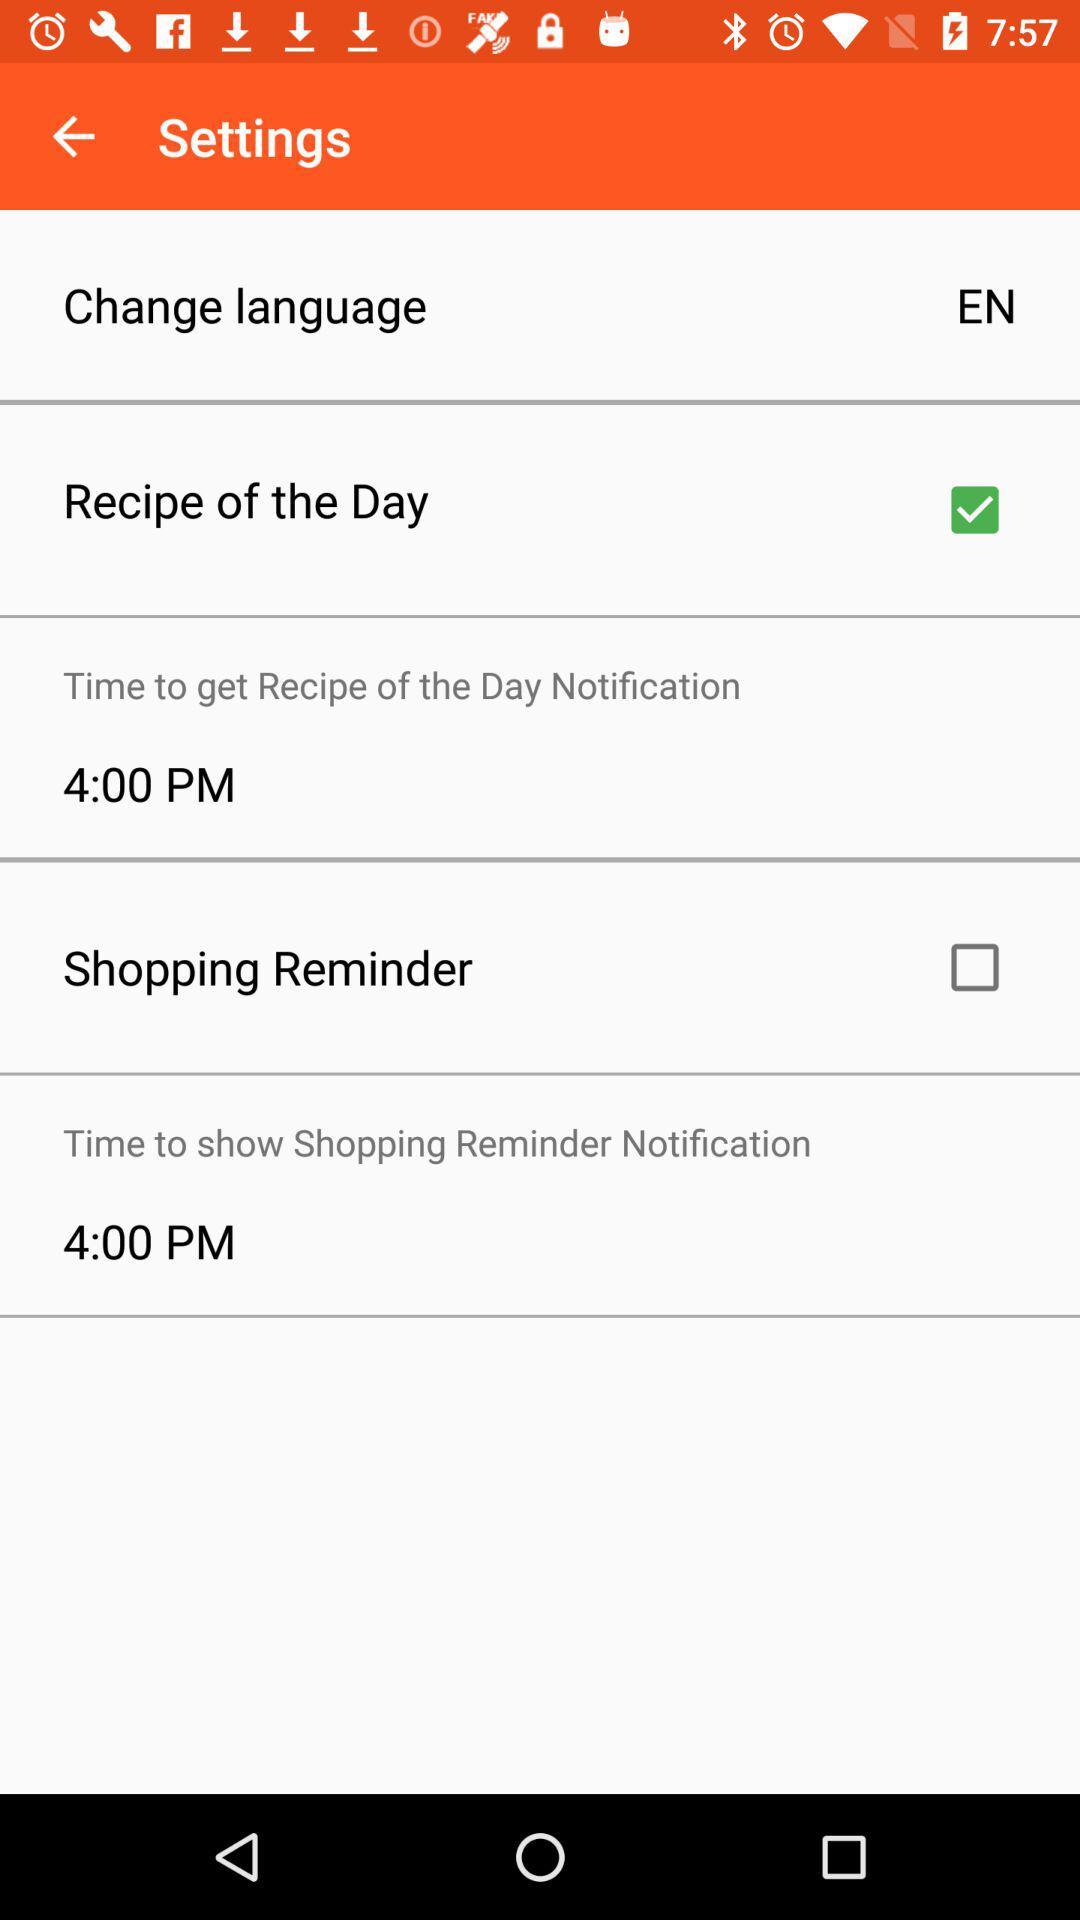What is the selected checkbox? The selected checkbox is "Recipe of the Day". 